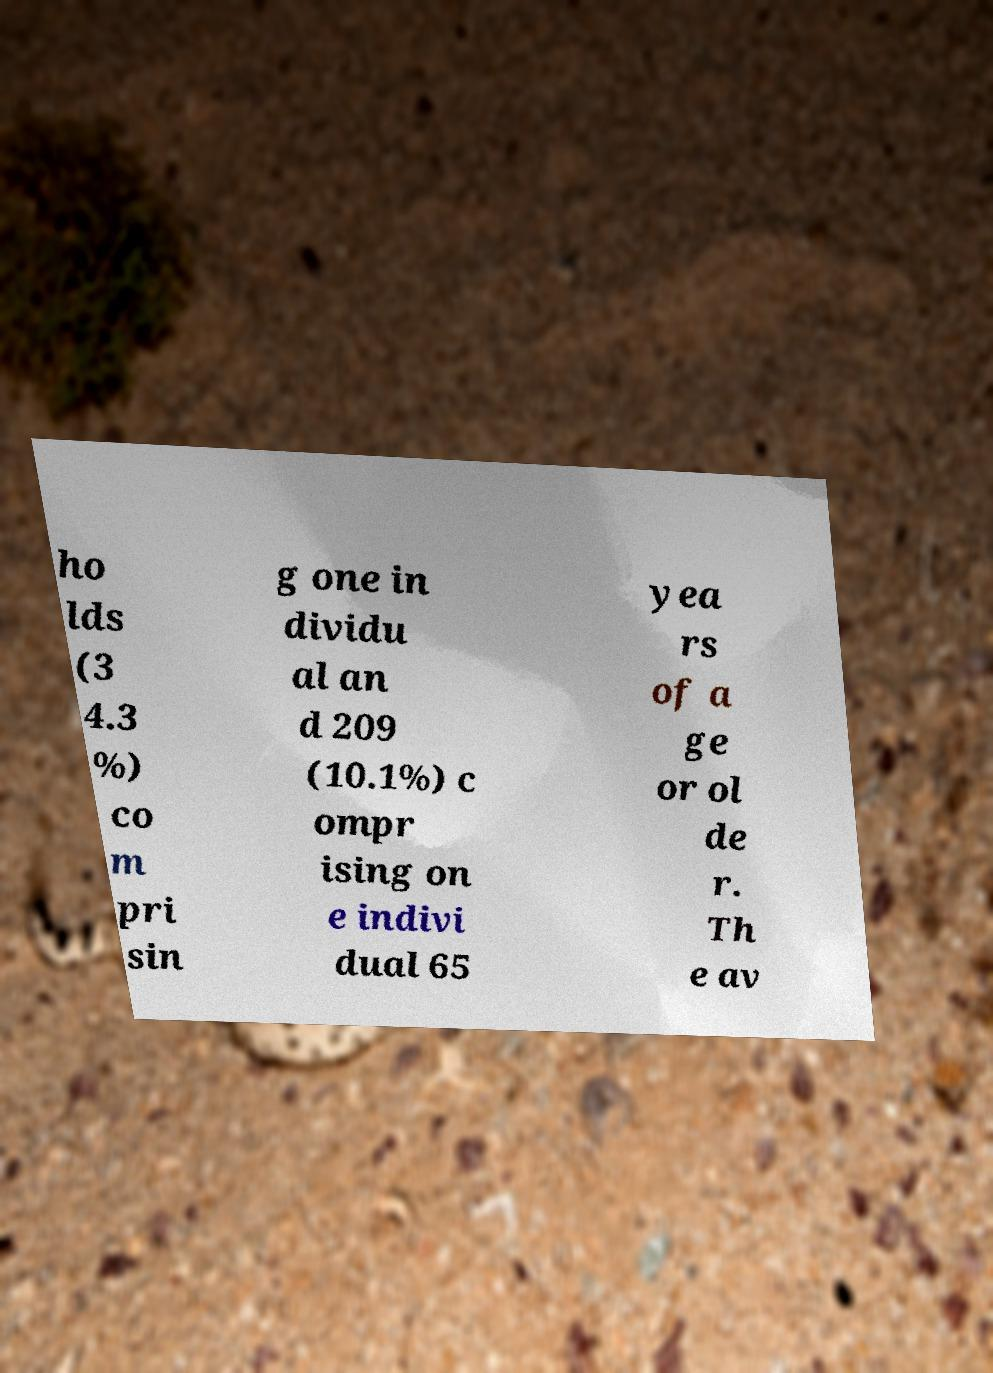For documentation purposes, I need the text within this image transcribed. Could you provide that? ho lds (3 4.3 %) co m pri sin g one in dividu al an d 209 (10.1%) c ompr ising on e indivi dual 65 yea rs of a ge or ol de r. Th e av 